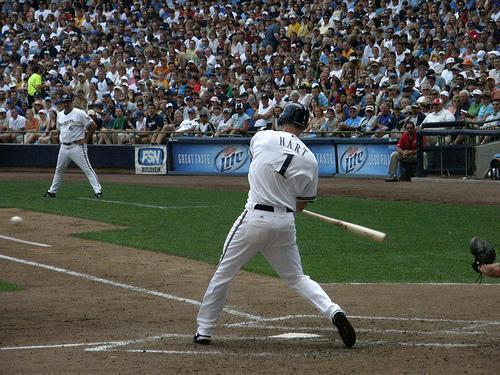According to the banner ad what kind of Lite beer tastes great?
Choose the correct response and explain in the format: 'Answer: answer
Rationale: rationale.'
Options: Heineken, miller, corona, bud. Answer: miller.
Rationale: The beer is miller lite. 